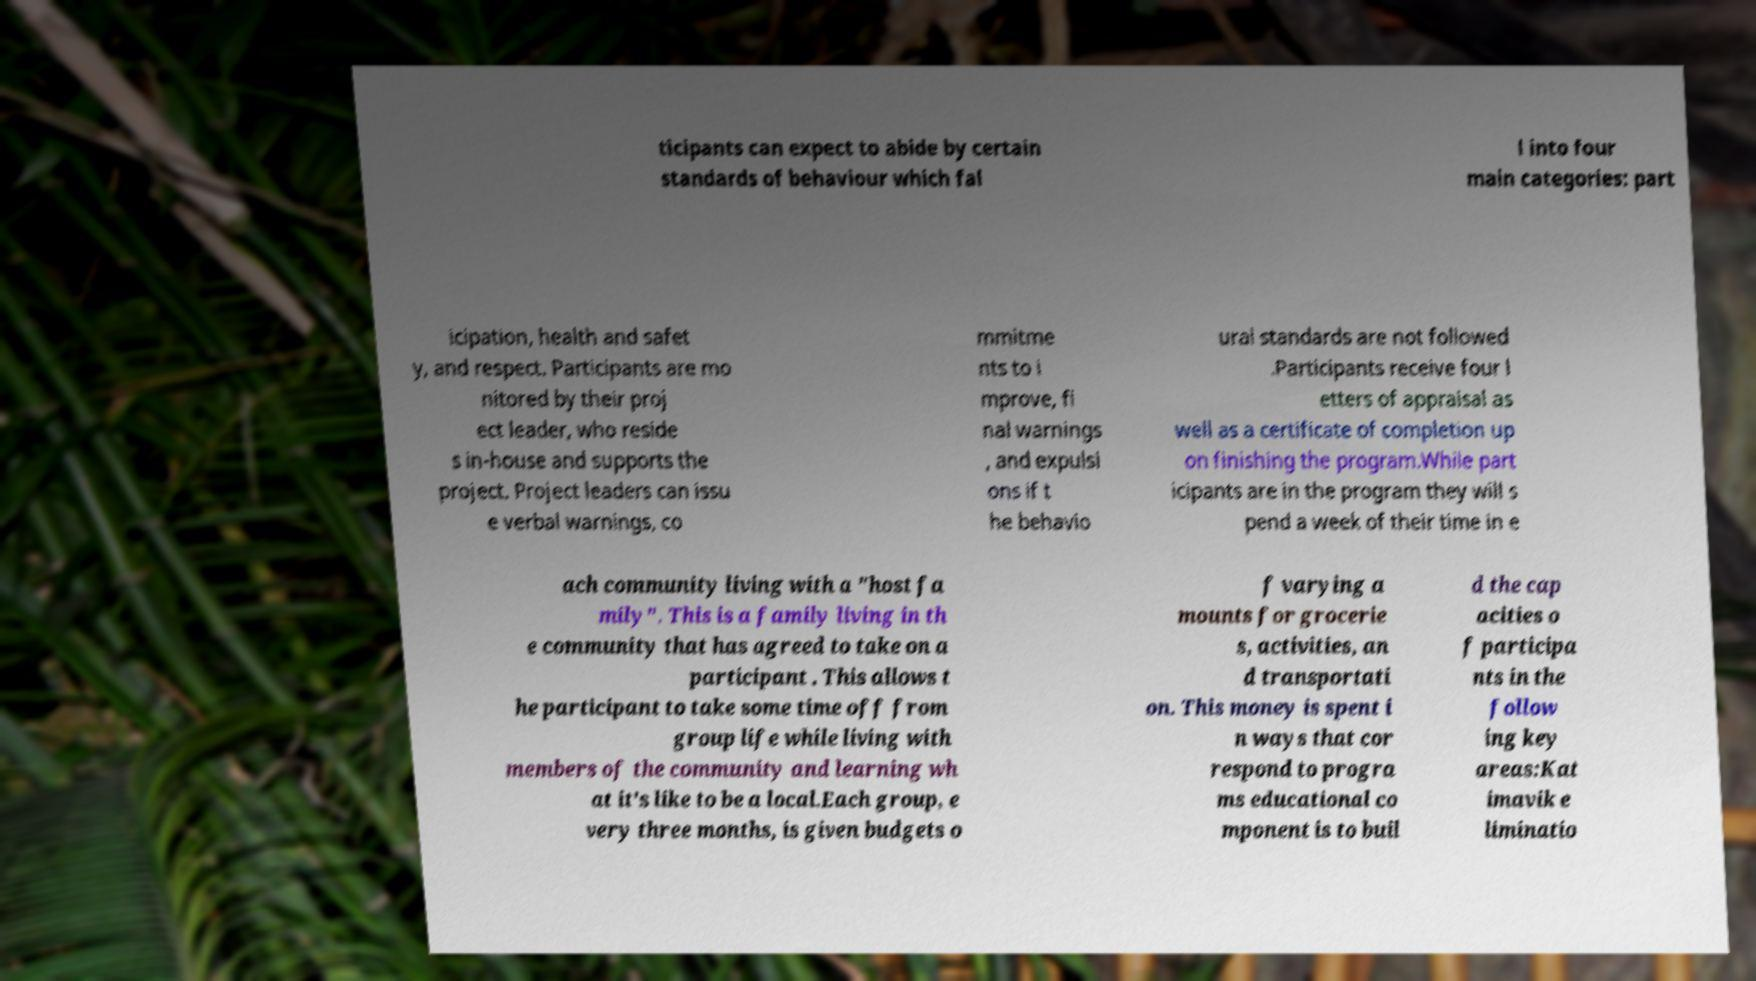For documentation purposes, I need the text within this image transcribed. Could you provide that? ticipants can expect to abide by certain standards of behaviour which fal l into four main categories: part icipation, health and safet y, and respect. Participants are mo nitored by their proj ect leader, who reside s in-house and supports the project. Project leaders can issu e verbal warnings, co mmitme nts to i mprove, fi nal warnings , and expulsi ons if t he behavio ural standards are not followed .Participants receive four l etters of appraisal as well as a certificate of completion up on finishing the program.While part icipants are in the program they will s pend a week of their time in e ach community living with a "host fa mily". This is a family living in th e community that has agreed to take on a participant . This allows t he participant to take some time off from group life while living with members of the community and learning wh at it's like to be a local.Each group, e very three months, is given budgets o f varying a mounts for grocerie s, activities, an d transportati on. This money is spent i n ways that cor respond to progra ms educational co mponent is to buil d the cap acities o f participa nts in the follow ing key areas:Kat imavik e liminatio 